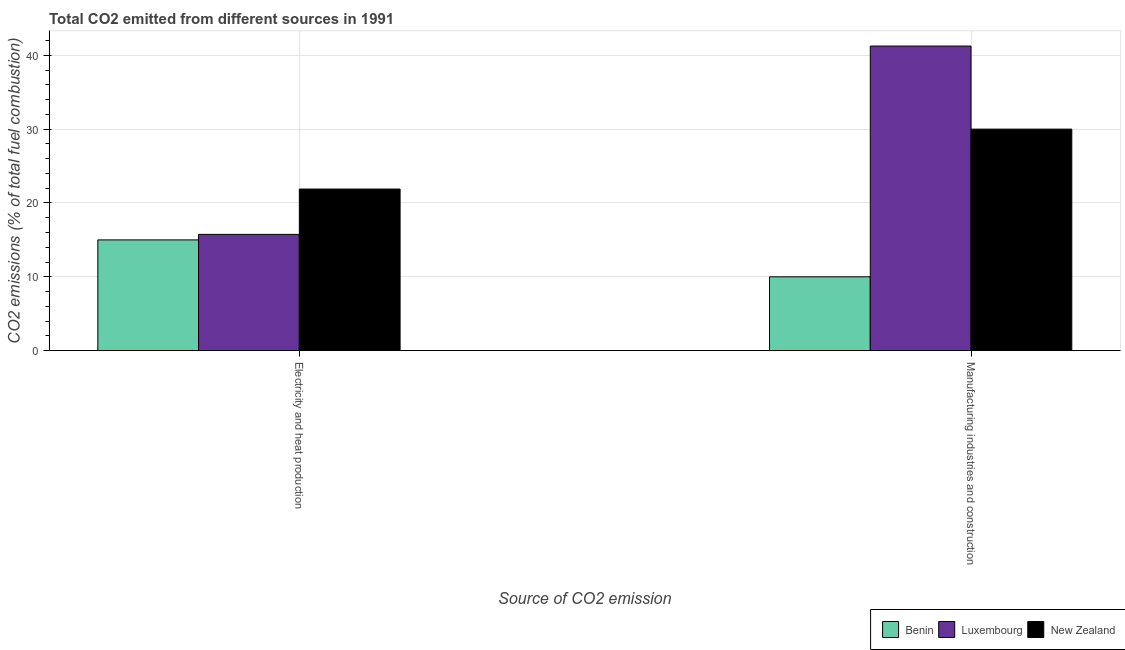How many different coloured bars are there?
Make the answer very short. 3. How many bars are there on the 1st tick from the right?
Give a very brief answer. 3. What is the label of the 2nd group of bars from the left?
Provide a short and direct response. Manufacturing industries and construction. What is the co2 emissions due to electricity and heat production in Benin?
Provide a succinct answer. 15. Across all countries, what is the maximum co2 emissions due to electricity and heat production?
Offer a terse response. 21.89. In which country was the co2 emissions due to electricity and heat production maximum?
Your answer should be compact. New Zealand. In which country was the co2 emissions due to electricity and heat production minimum?
Keep it short and to the point. Benin. What is the total co2 emissions due to electricity and heat production in the graph?
Offer a terse response. 52.63. What is the difference between the co2 emissions due to electricity and heat production in Luxembourg and that in Benin?
Give a very brief answer. 0.75. What is the difference between the co2 emissions due to manufacturing industries in Luxembourg and the co2 emissions due to electricity and heat production in Benin?
Make the answer very short. 26.25. What is the average co2 emissions due to electricity and heat production per country?
Provide a succinct answer. 17.54. What is the difference between the co2 emissions due to electricity and heat production and co2 emissions due to manufacturing industries in Benin?
Ensure brevity in your answer.  5. What is the ratio of the co2 emissions due to electricity and heat production in Luxembourg to that in New Zealand?
Your answer should be compact. 0.72. What does the 2nd bar from the left in Manufacturing industries and construction represents?
Your response must be concise. Luxembourg. What does the 3rd bar from the right in Electricity and heat production represents?
Offer a terse response. Benin. Does the graph contain any zero values?
Make the answer very short. No. Where does the legend appear in the graph?
Provide a short and direct response. Bottom right. How are the legend labels stacked?
Your answer should be compact. Horizontal. What is the title of the graph?
Your answer should be compact. Total CO2 emitted from different sources in 1991. Does "Sub-Saharan Africa (developing only)" appear as one of the legend labels in the graph?
Your response must be concise. No. What is the label or title of the X-axis?
Offer a very short reply. Source of CO2 emission. What is the label or title of the Y-axis?
Keep it short and to the point. CO2 emissions (% of total fuel combustion). What is the CO2 emissions (% of total fuel combustion) of Luxembourg in Electricity and heat production?
Offer a terse response. 15.75. What is the CO2 emissions (% of total fuel combustion) in New Zealand in Electricity and heat production?
Provide a short and direct response. 21.89. What is the CO2 emissions (% of total fuel combustion) of Luxembourg in Manufacturing industries and construction?
Your answer should be very brief. 41.25. Across all Source of CO2 emission, what is the maximum CO2 emissions (% of total fuel combustion) in Luxembourg?
Keep it short and to the point. 41.25. Across all Source of CO2 emission, what is the minimum CO2 emissions (% of total fuel combustion) in Luxembourg?
Provide a succinct answer. 15.75. Across all Source of CO2 emission, what is the minimum CO2 emissions (% of total fuel combustion) in New Zealand?
Provide a succinct answer. 21.89. What is the total CO2 emissions (% of total fuel combustion) in Benin in the graph?
Your response must be concise. 25. What is the total CO2 emissions (% of total fuel combustion) in Luxembourg in the graph?
Your answer should be very brief. 57. What is the total CO2 emissions (% of total fuel combustion) in New Zealand in the graph?
Make the answer very short. 51.89. What is the difference between the CO2 emissions (% of total fuel combustion) in Benin in Electricity and heat production and that in Manufacturing industries and construction?
Your answer should be very brief. 5. What is the difference between the CO2 emissions (% of total fuel combustion) in Luxembourg in Electricity and heat production and that in Manufacturing industries and construction?
Make the answer very short. -25.51. What is the difference between the CO2 emissions (% of total fuel combustion) in New Zealand in Electricity and heat production and that in Manufacturing industries and construction?
Your answer should be very brief. -8.11. What is the difference between the CO2 emissions (% of total fuel combustion) of Benin in Electricity and heat production and the CO2 emissions (% of total fuel combustion) of Luxembourg in Manufacturing industries and construction?
Offer a terse response. -26.25. What is the difference between the CO2 emissions (% of total fuel combustion) of Luxembourg in Electricity and heat production and the CO2 emissions (% of total fuel combustion) of New Zealand in Manufacturing industries and construction?
Keep it short and to the point. -14.25. What is the average CO2 emissions (% of total fuel combustion) in Benin per Source of CO2 emission?
Offer a very short reply. 12.5. What is the average CO2 emissions (% of total fuel combustion) in Luxembourg per Source of CO2 emission?
Ensure brevity in your answer.  28.5. What is the average CO2 emissions (% of total fuel combustion) of New Zealand per Source of CO2 emission?
Your answer should be compact. 25.94. What is the difference between the CO2 emissions (% of total fuel combustion) of Benin and CO2 emissions (% of total fuel combustion) of Luxembourg in Electricity and heat production?
Give a very brief answer. -0.75. What is the difference between the CO2 emissions (% of total fuel combustion) in Benin and CO2 emissions (% of total fuel combustion) in New Zealand in Electricity and heat production?
Keep it short and to the point. -6.89. What is the difference between the CO2 emissions (% of total fuel combustion) in Luxembourg and CO2 emissions (% of total fuel combustion) in New Zealand in Electricity and heat production?
Keep it short and to the point. -6.14. What is the difference between the CO2 emissions (% of total fuel combustion) of Benin and CO2 emissions (% of total fuel combustion) of Luxembourg in Manufacturing industries and construction?
Make the answer very short. -31.25. What is the difference between the CO2 emissions (% of total fuel combustion) in Luxembourg and CO2 emissions (% of total fuel combustion) in New Zealand in Manufacturing industries and construction?
Make the answer very short. 11.25. What is the ratio of the CO2 emissions (% of total fuel combustion) in Luxembourg in Electricity and heat production to that in Manufacturing industries and construction?
Your answer should be compact. 0.38. What is the ratio of the CO2 emissions (% of total fuel combustion) of New Zealand in Electricity and heat production to that in Manufacturing industries and construction?
Your answer should be very brief. 0.73. What is the difference between the highest and the second highest CO2 emissions (% of total fuel combustion) in Benin?
Your answer should be compact. 5. What is the difference between the highest and the second highest CO2 emissions (% of total fuel combustion) of Luxembourg?
Offer a very short reply. 25.51. What is the difference between the highest and the second highest CO2 emissions (% of total fuel combustion) in New Zealand?
Your answer should be very brief. 8.11. What is the difference between the highest and the lowest CO2 emissions (% of total fuel combustion) of Luxembourg?
Your response must be concise. 25.51. What is the difference between the highest and the lowest CO2 emissions (% of total fuel combustion) of New Zealand?
Give a very brief answer. 8.11. 